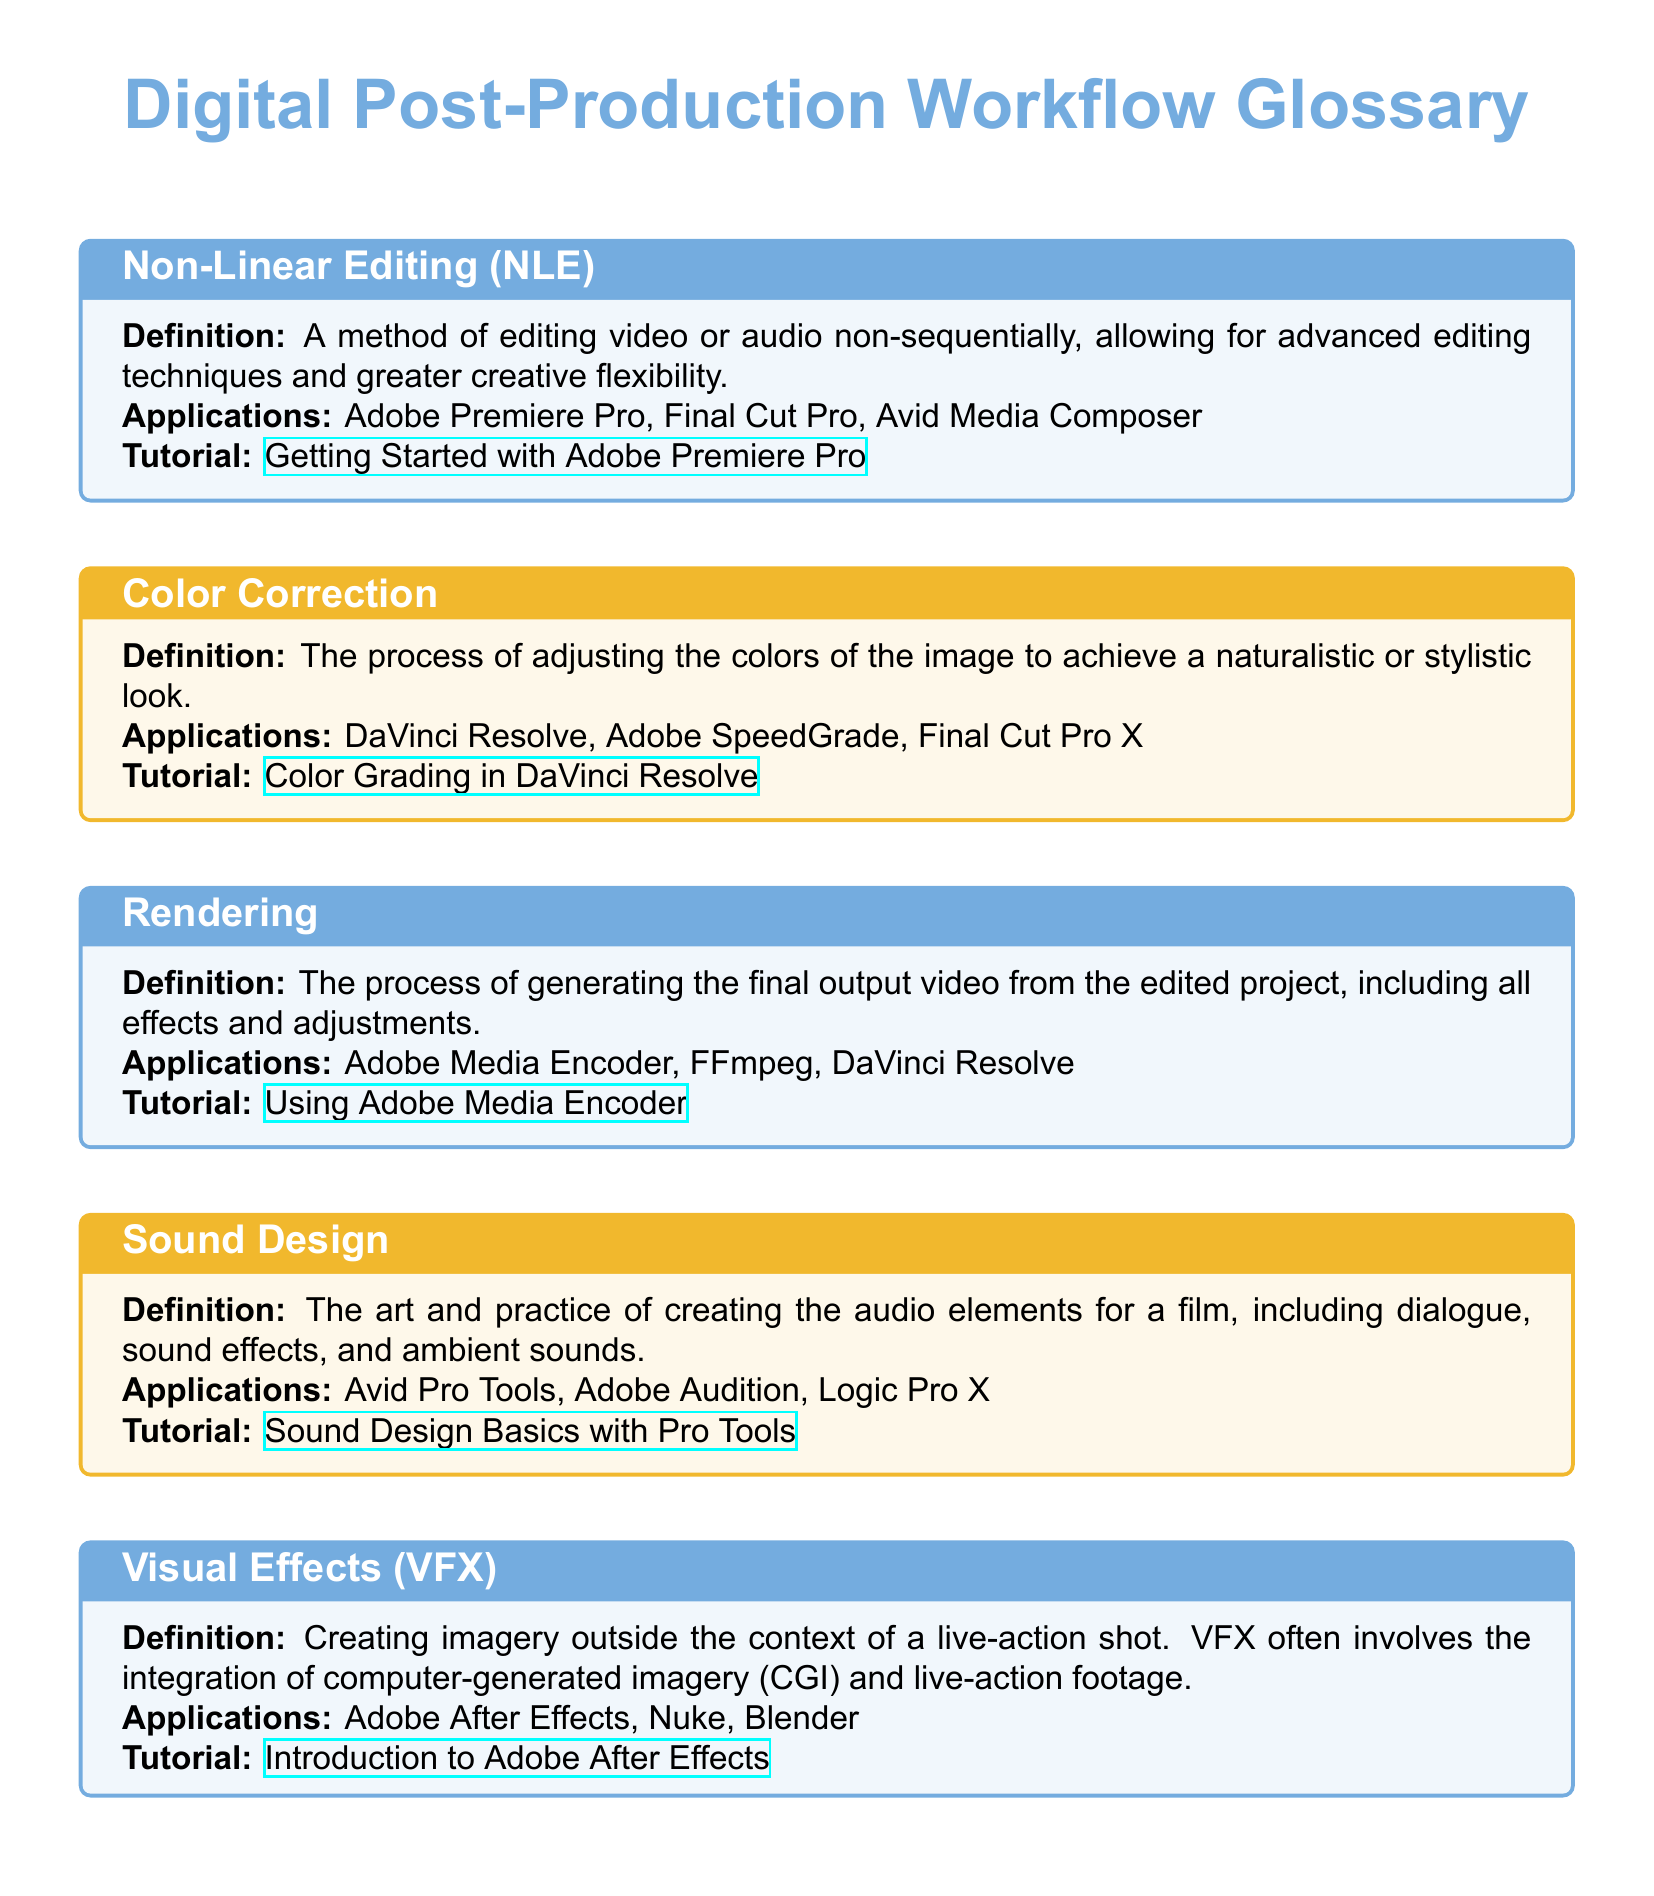What is Non-Linear Editing abbreviated as? Non-Linear Editing is commonly referred to by its acronym NLE in the document.
Answer: NLE Which software is recommended for Color Correction? DaVinci Resolve is listed as one of the applications for Color Correction in the document.
Answer: DaVinci Resolve What is the main purpose of Rendering? The document states that Rendering is the process of generating the final output video from the edited project.
Answer: Final output video What is one of the applications used for Sound Design? Avid Pro Tools is mentioned as an application used for Sound Design in the document.
Answer: Avid Pro Tools What process involves creating imagery outside the context of a live-action shot? Visual Effects (VFX) is described in the document as the process of creating imagery outside the context of a live-action shot.
Answer: Visual Effects (VFX) Which tutorial is linked for learning about Adobe After Effects? The tutorial for Adobe After Effects is titled 'Introduction to Adobe After Effects' in the document.
Answer: Introduction to Adobe After Effects How many applications are provided for Visual Effects (VFX)? The document lists three applications under Visual Effects (VFX).
Answer: Three What color is used for the header in the document? The header uses the color argentineblue as specified in the document.
Answer: argentineblue Which software is used for Rendering? Adobe Media Encoder is listed among applications for Rendering in the document.
Answer: Adobe Media Encoder 